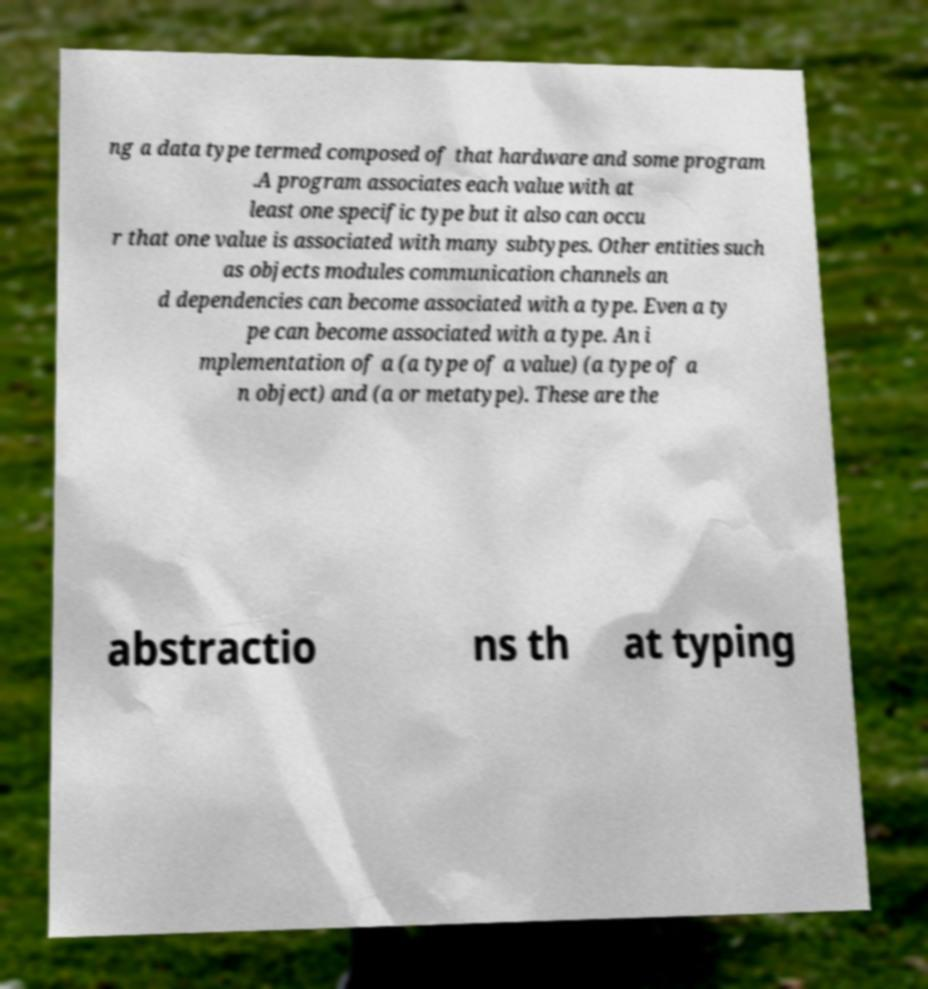Can you read and provide the text displayed in the image?This photo seems to have some interesting text. Can you extract and type it out for me? ng a data type termed composed of that hardware and some program .A program associates each value with at least one specific type but it also can occu r that one value is associated with many subtypes. Other entities such as objects modules communication channels an d dependencies can become associated with a type. Even a ty pe can become associated with a type. An i mplementation of a (a type of a value) (a type of a n object) and (a or metatype). These are the abstractio ns th at typing 